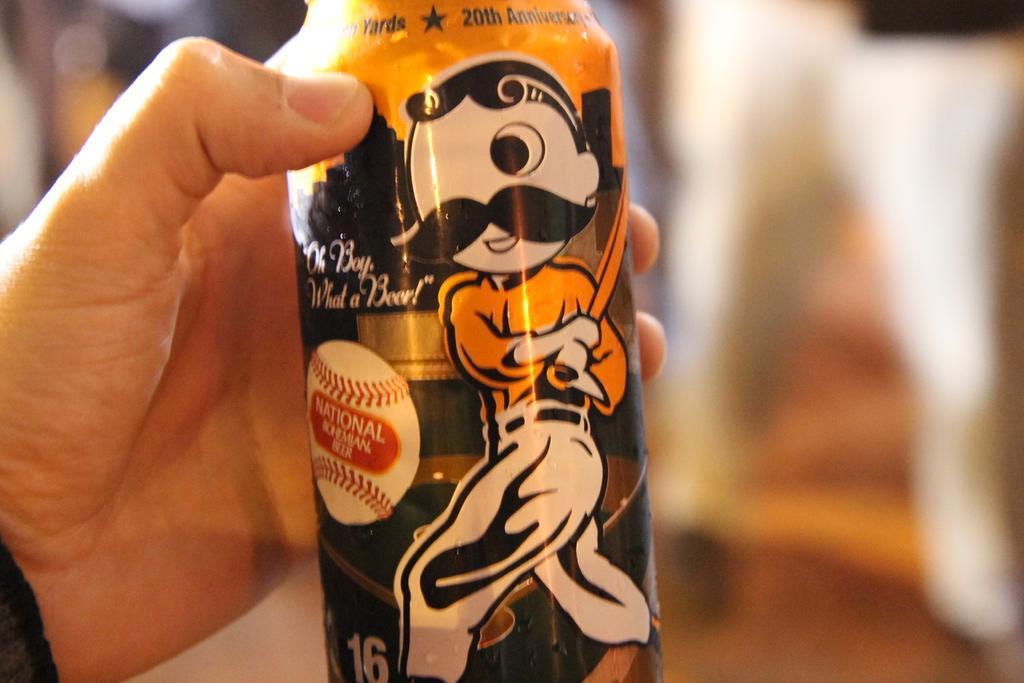How would you summarize this image in a sentence or two? In this image, I can see a person's hand holding a bottle. The background looks blurry. I can see the pictures on the bottle. 